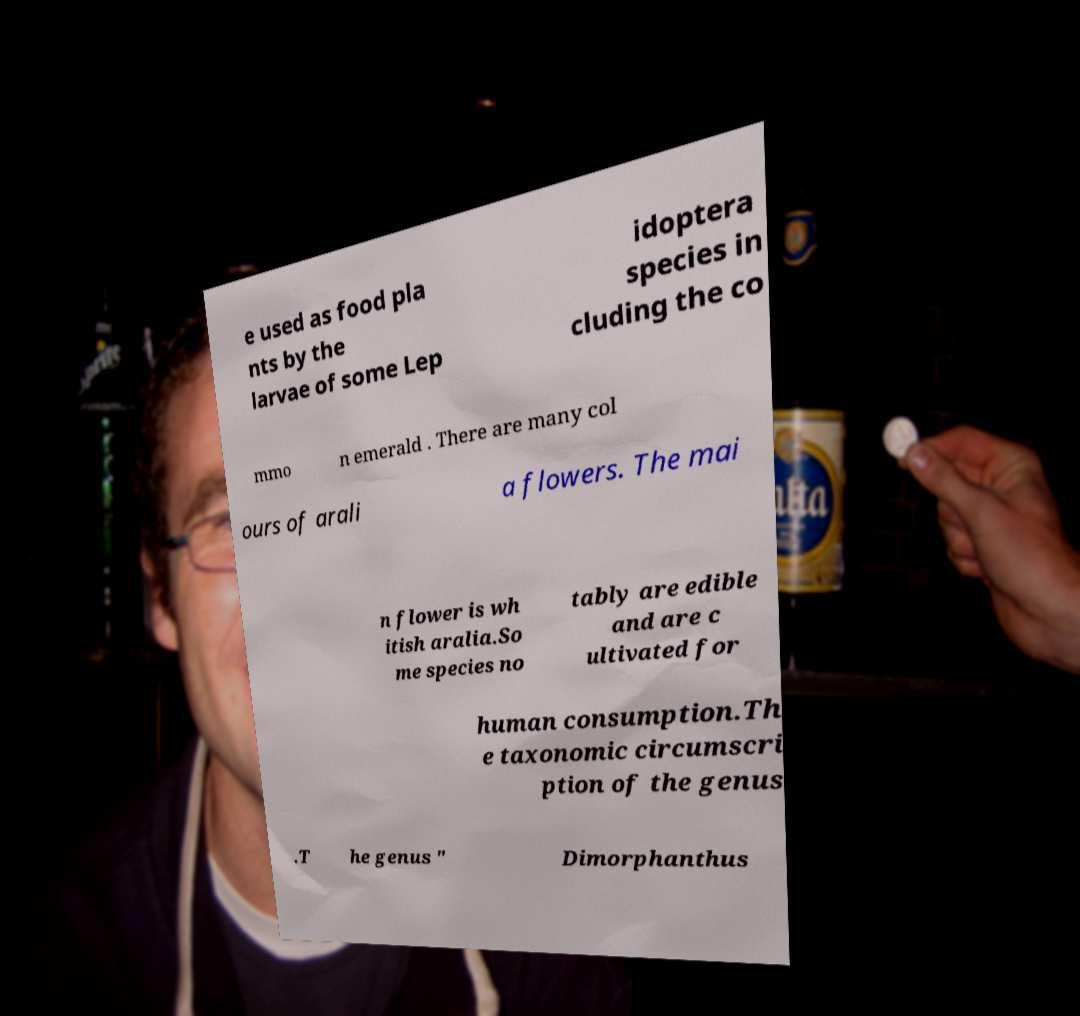Please read and relay the text visible in this image. What does it say? e used as food pla nts by the larvae of some Lep idoptera species in cluding the co mmo n emerald . There are many col ours of arali a flowers. The mai n flower is wh itish aralia.So me species no tably are edible and are c ultivated for human consumption.Th e taxonomic circumscri ption of the genus .T he genus " Dimorphanthus 